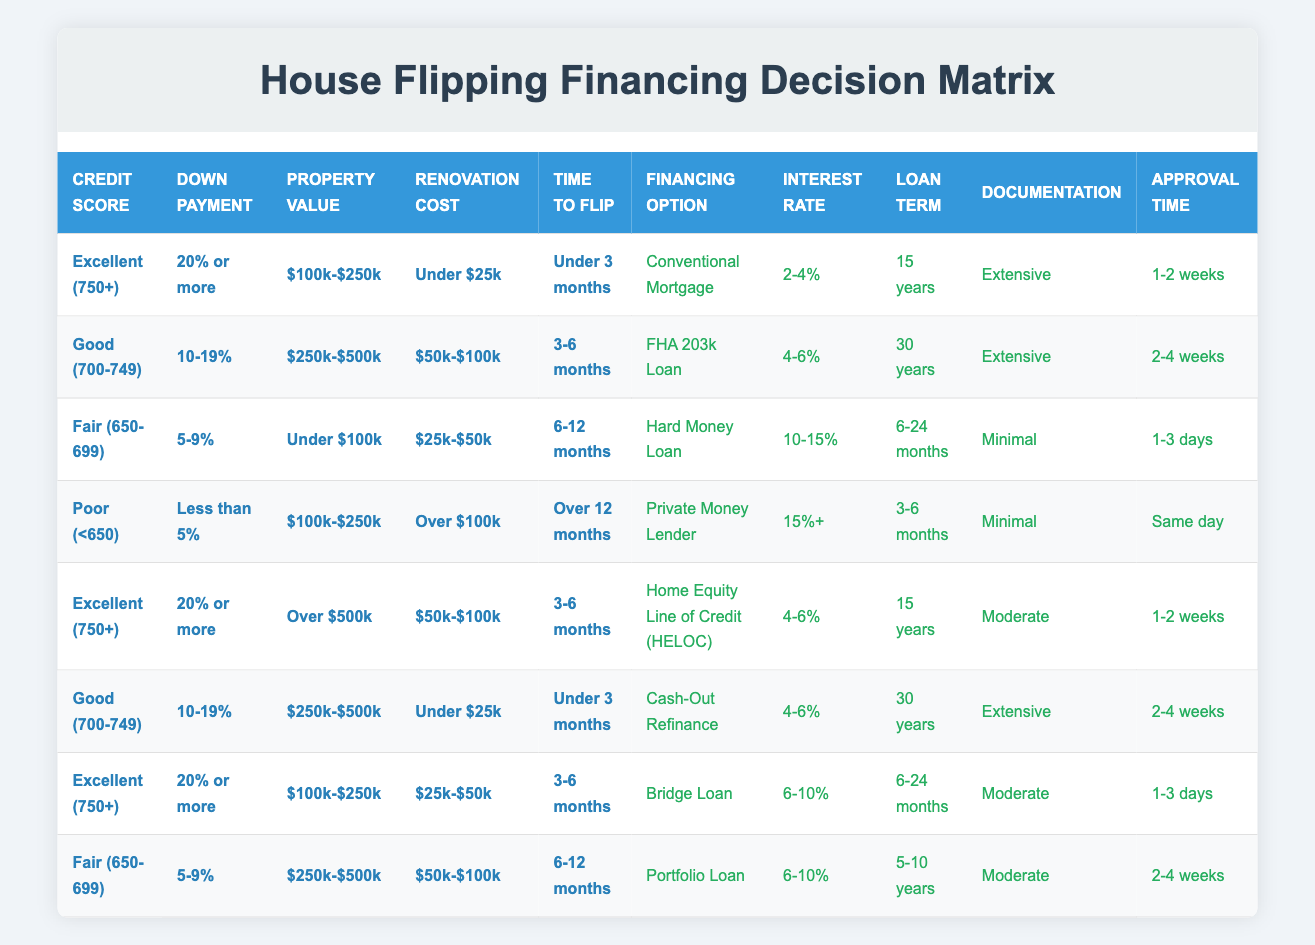What financing option is available if the credit score is Good (700-749), down payment is 10-19%, property value is $250k-$500k, renovation cost is $50k-$100k, and expected time to flip is 3-6 months? By looking at the table, I find the row with these exact conditions. It shows the financing option of "FHA 203k Loan."
Answer: FHA 203k Loan Is a Conventional Mortgage available for those with a credit score of Excellent (750+) and less than 5% down payment? I review the "Credit Score" and "Down Payment" columns to find if any row matches these conditions. None of the rows with Excellent credit allow for less than 5% down payment.
Answer: No What is the interest rate associated with a Hard Money Loan for someone with Fair credit (650-699), a down payment of 5-9%, property value of under $100k, renovation cost between $25k-$50k, and an expected flip time of 6-12 months? I scan the table for the row where these conditions match. It shows that the Hard Money Loan has an interest rate of "10-15%."
Answer: 10-15% How many financing options are available for someone with Excellent credit (750+) and a property value of over $500k? I look for rows that meet the criteria of Excellent credit and property value over $500k. There are two rows that fit this condition: one for the Home Equity Line of Credit and another for the Bridge Loan. Thus, there are 2 options.
Answer: 2 What is the required documentation for a Private Money Lender with less than 5% down payment, credit score under 650, property value between $100k-$250k, renovation cost over $100k, and a flip time of over 12 months? I check the corresponding row in the table that describes these conditions. It states that the required documentation is "Minimal."
Answer: Minimal What loan term can be expected for a financing option with an interest rate of 4-6%? I analyze all the matching interest rates to find that options include a loan term of "15 years" for a Conventional Mortgage and "30 years" for both FHA 203k Loan and Cash-Out Refinance. There are three distinct terms associated with the interest rate of 4-6%.
Answer: 15 years, 30 years Which financing option has the shortest approval time based on the conditions in the table? I review the "Approval Time" column to examine all the options. The same-day approval is available for the Private Money Lender. This represents the shortest approval time compared to others listed.
Answer: Same day What are the average interest rates for financing options that require extensive documentation? Rows requiring extensive documentation include Conventional Mortgage (2-4%), FHA 203k Loan (4-6%), and Cash-Out Refinance (4-6%). The total interest rates are (2+4+4) = 10%, divided by the 3 loans gives an average of 3.33%, which rounds to approximately 3.3%.
Answer: 3.3% 